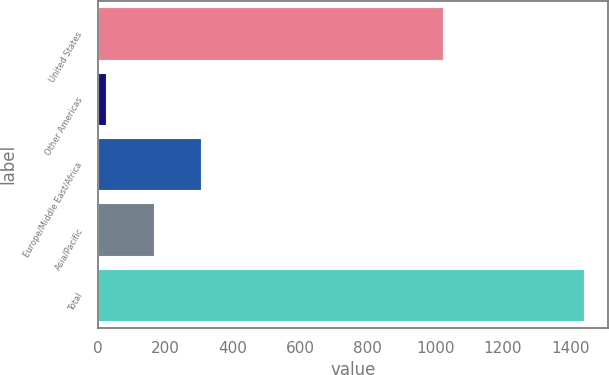<chart> <loc_0><loc_0><loc_500><loc_500><bar_chart><fcel>United States<fcel>Other Americas<fcel>Europe/Middle East/Africa<fcel>Asia/Pacific<fcel>Total<nl><fcel>1023<fcel>24<fcel>307.4<fcel>165.7<fcel>1441<nl></chart> 